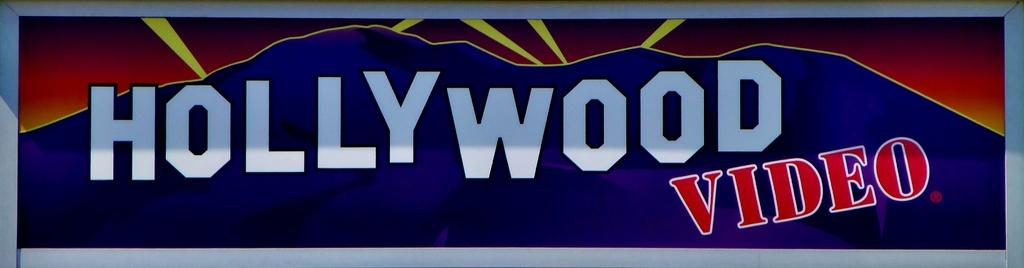<image>
Summarize the visual content of the image. A sign for Hollywood Video shows blue mountains with yellow lights behind it 